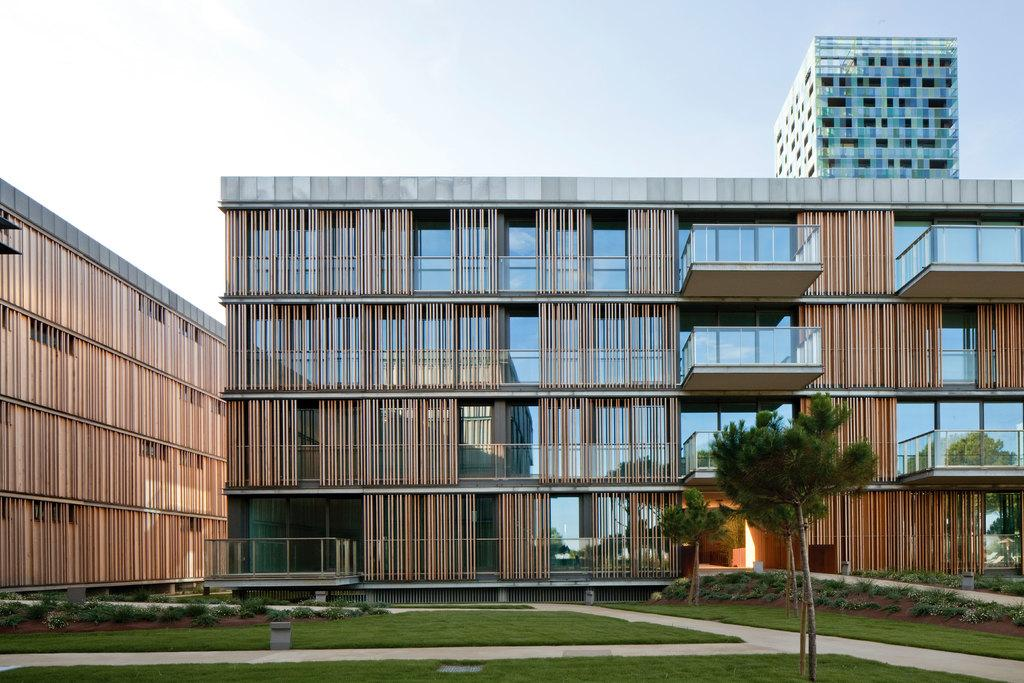What type of structures can be seen in the image? There are buildings in the image. What type of vegetation is visible in the image? There is grass and trees visible in the image. What part of the natural environment is visible in the image? The sky is visible in the background of the image. What color is the shirt worn by the men in the image? There are no men or shirts present in the image. Can you hear a whistle in the image? There is no sound or whistle present in the image. 